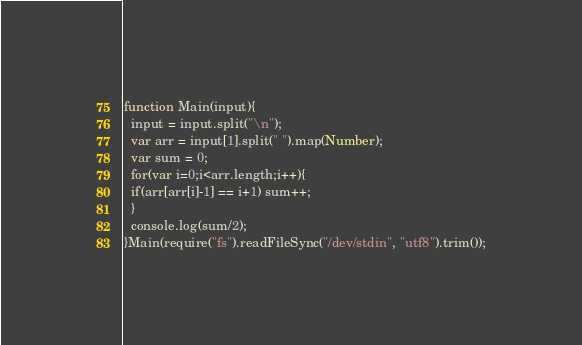<code> <loc_0><loc_0><loc_500><loc_500><_JavaScript_>function Main(input){
  input = input.split("\n");
  var arr = input[1].split(" ").map(Number);
  var sum = 0;
  for(var i=0;i<arr.length;i++){
  if(arr[arr[i]-1] == i+1) sum++;
  }
  console.log(sum/2);
}Main(require("fs").readFileSync("/dev/stdin", "utf8").trim());</code> 